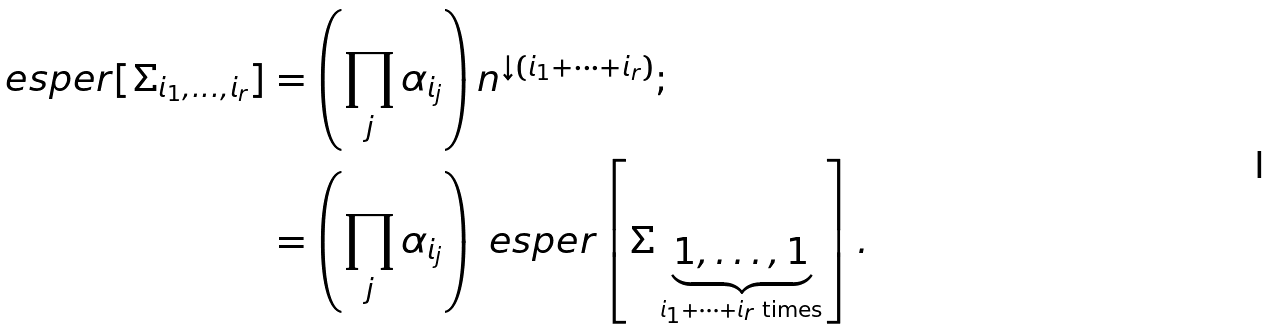<formula> <loc_0><loc_0><loc_500><loc_500>\ e s p e r [ \varSigma _ { i _ { 1 } , \dots , i _ { r } } ] & = \left ( \prod _ { j } \alpha _ { i _ { j } } \right ) n ^ { \downarrow ( i _ { 1 } + \cdots + i _ { r } ) } ; \\ & = \left ( \prod _ { j } \alpha _ { i _ { j } } \right ) \ e s p e r \left [ \varSigma _ { \, \underbrace { 1 , \dots , 1 } _ { i _ { 1 } + \cdots + i _ { r } \text { times} } } \right ] .</formula> 